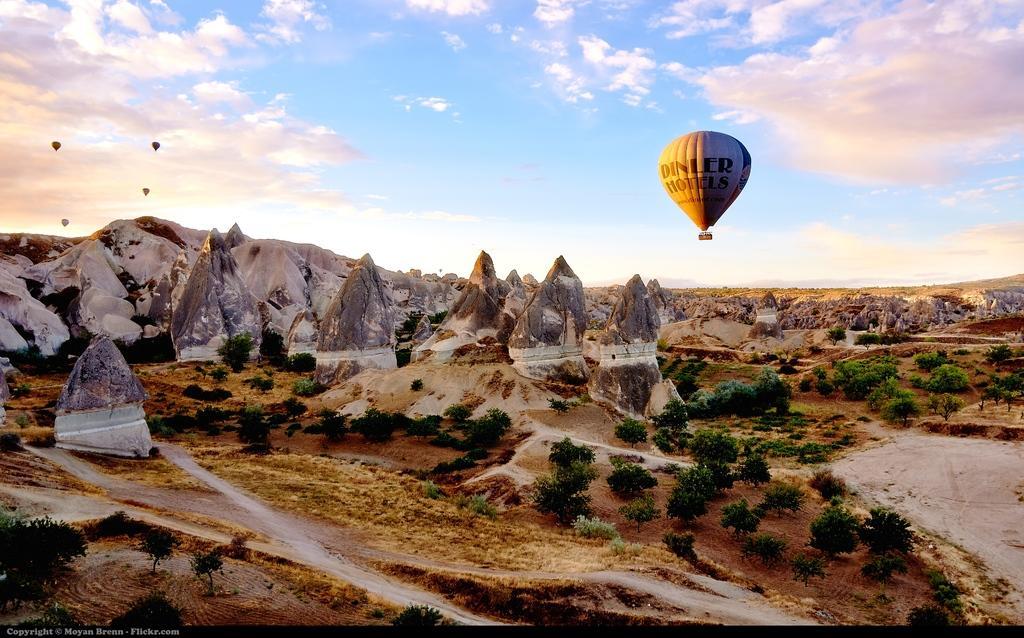Describe this image in one or two sentences. In this picture we can see a land of mountains, trees, path and above the mountains it is a sky so cloudy and we can see parachutes on the sky. 